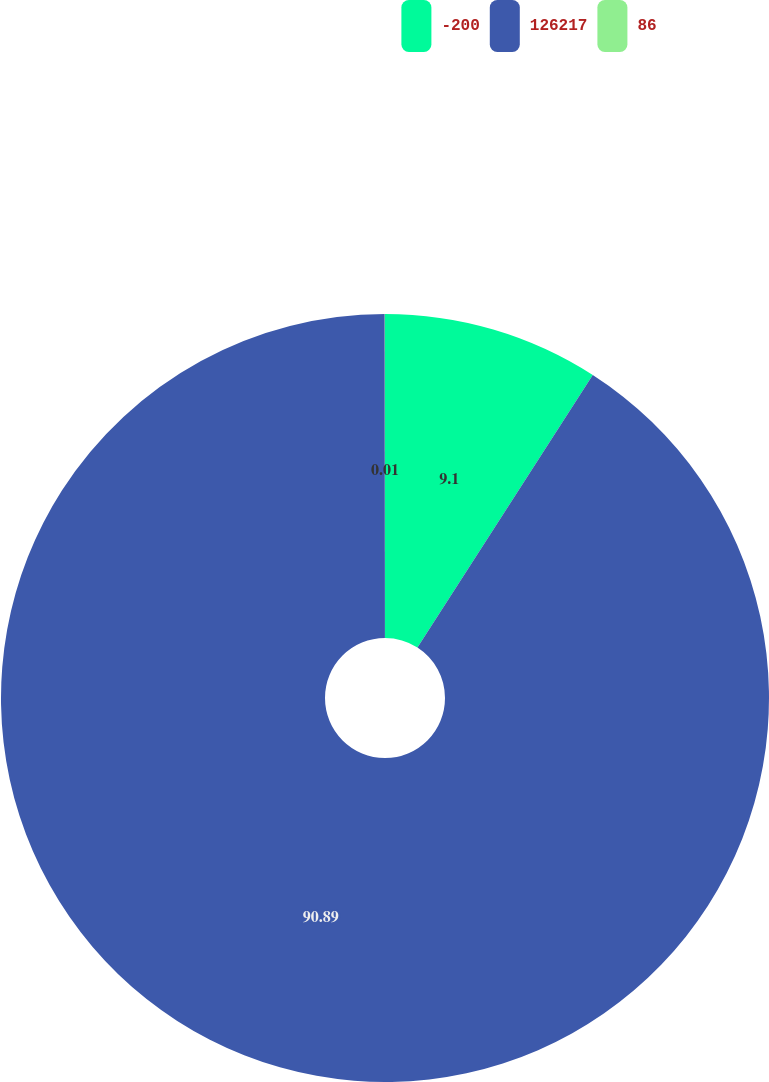Convert chart to OTSL. <chart><loc_0><loc_0><loc_500><loc_500><pie_chart><fcel>-200<fcel>126217<fcel>86<nl><fcel>9.1%<fcel>90.9%<fcel>0.01%<nl></chart> 